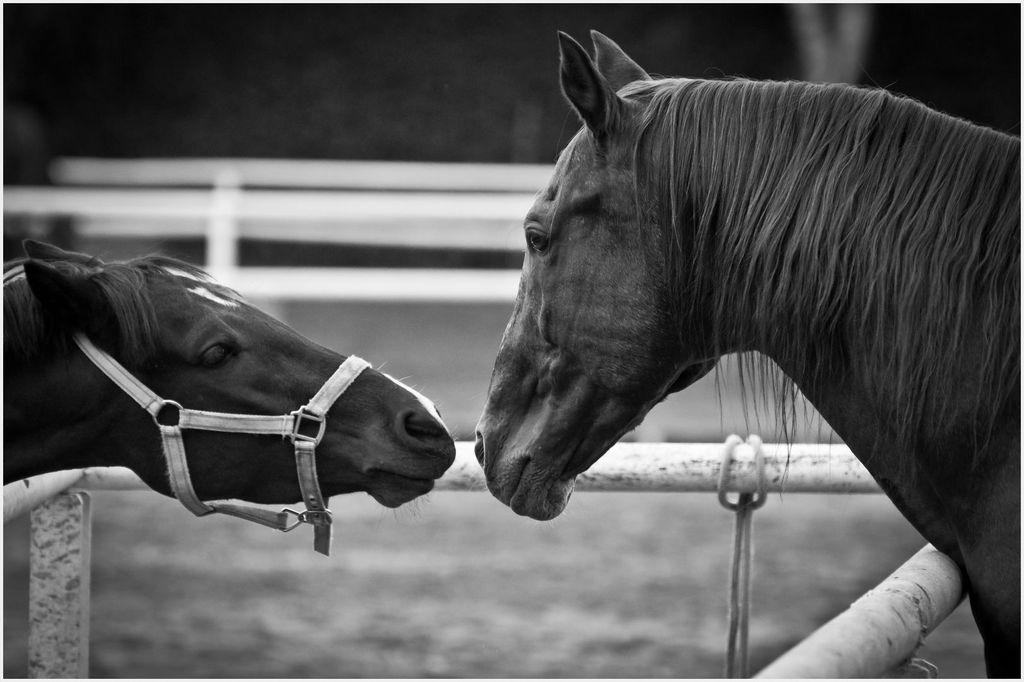Could you give a brief overview of what you see in this image? This is a black and white image. Here I can see two horses are staring at each other. At the bottom I can see few metal rods. The background is blurred. 